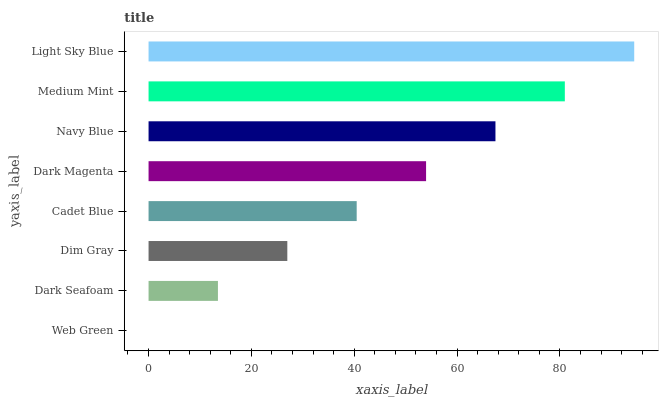Is Web Green the minimum?
Answer yes or no. Yes. Is Light Sky Blue the maximum?
Answer yes or no. Yes. Is Dark Seafoam the minimum?
Answer yes or no. No. Is Dark Seafoam the maximum?
Answer yes or no. No. Is Dark Seafoam greater than Web Green?
Answer yes or no. Yes. Is Web Green less than Dark Seafoam?
Answer yes or no. Yes. Is Web Green greater than Dark Seafoam?
Answer yes or no. No. Is Dark Seafoam less than Web Green?
Answer yes or no. No. Is Dark Magenta the high median?
Answer yes or no. Yes. Is Cadet Blue the low median?
Answer yes or no. Yes. Is Navy Blue the high median?
Answer yes or no. No. Is Web Green the low median?
Answer yes or no. No. 